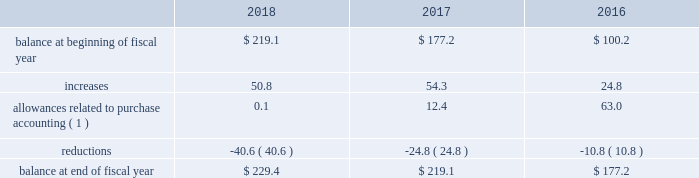Westrock company notes to consolidated financial statements fffd ( continued ) at september 30 , 2018 and september 30 , 2017 , gross net operating losses for foreign reporting purposes of approximately $ 698.4 million and $ 673.7 million , respectively , were available for carryforward .
A majority of these loss carryforwards generally expire between fiscal 2020 and 2038 , while a portion have an indefinite carryforward .
The tax effected values of these net operating losses are $ 185.8 million and $ 182.6 million at september 30 , 2018 and 2017 , respectively , exclusive of valuation allowances of $ 161.5 million and $ 149.6 million at september 30 , 2018 and 2017 , respectively .
At september 30 , 2018 and 2017 , we had state tax credit carryforwards of $ 64.8 million and $ 54.4 million , respectively .
These state tax credit carryforwards generally expire within 5 to 10 years ; however , certain state credits can be carried forward indefinitely .
Valuation allowances of $ 56.1 million and $ 47.3 million at september 30 , 2018 and 2017 , respectively , have been provided on these assets .
These valuation allowances have been recorded due to uncertainty regarding our ability to generate sufficient taxable income in the appropriate taxing jurisdiction .
The table represents a summary of the valuation allowances against deferred tax assets for fiscal 2018 , 2017 and 2016 ( in millions ) : .
( 1 ) amounts in fiscal 2018 and 2017 relate to the mps acquisition .
Adjustments in fiscal 2016 relate to the combination and the sp fiber acquisition .
Consistent with prior years , we consider a portion of our earnings from certain foreign subsidiaries as subject to repatriation and we provide for taxes accordingly .
However , we consider the unremitted earnings and all other outside basis differences from all other foreign subsidiaries to be indefinitely reinvested .
Accordingly , we have not provided for any taxes that would be due .
As of september 30 , 2018 , we estimate our outside basis difference in foreign subsidiaries that are considered indefinitely reinvested to be approximately $ 1.5 billion .
The components of the outside basis difference are comprised of purchase accounting adjustments , undistributed earnings , and equity components .
Except for the portion of our earnings from certain foreign subsidiaries where we provided for taxes , we have not provided for any taxes that would be due upon the reversal of the outside basis differences .
However , in the event of a distribution in the form of dividends or dispositions of the subsidiaries , we may be subject to incremental u.s .
Income taxes , subject to an adjustment for foreign tax credits , and withholding taxes or income taxes payable to the foreign jurisdictions .
As of september 30 , 2018 , the determination of the amount of unrecognized deferred tax liability related to any remaining undistributed foreign earnings not subject to the transition tax and additional outside basis differences is not practicable. .
By what percent did the value of reductions increase between 2016 and 2018? 
Computations: ((40.6 / 10.8) / 10.8)
Answer: 0.34808. 